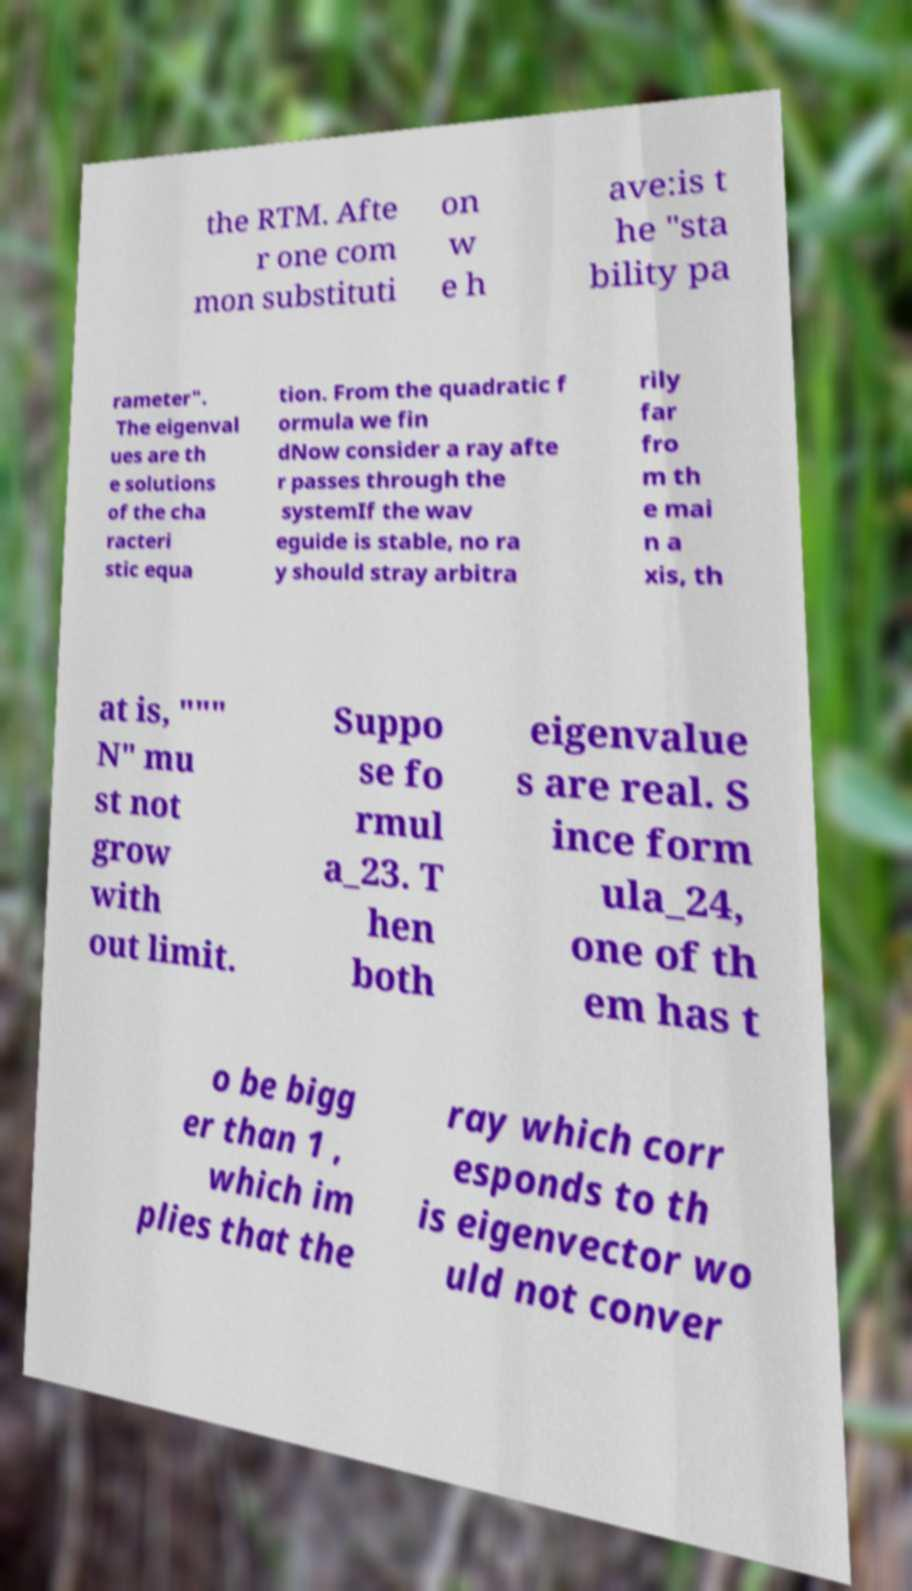For documentation purposes, I need the text within this image transcribed. Could you provide that? the RTM. Afte r one com mon substituti on w e h ave:is t he "sta bility pa rameter". The eigenval ues are th e solutions of the cha racteri stic equa tion. From the quadratic f ormula we fin dNow consider a ray afte r passes through the systemIf the wav eguide is stable, no ra y should stray arbitra rily far fro m th e mai n a xis, th at is, """ N" mu st not grow with out limit. Suppo se fo rmul a_23. T hen both eigenvalue s are real. S ince form ula_24, one of th em has t o be bigg er than 1 , which im plies that the ray which corr esponds to th is eigenvector wo uld not conver 